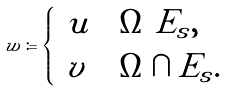<formula> <loc_0><loc_0><loc_500><loc_500>w \coloneqq \begin{cases} \ u & \Omega \ E _ { s } , \\ \ v & \Omega \cap E _ { s } . \end{cases}</formula> 